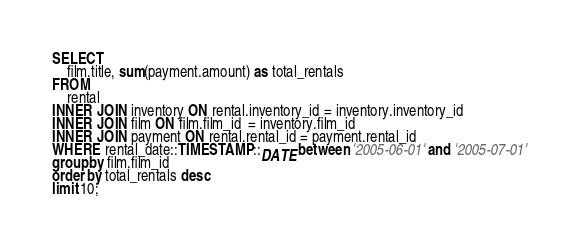Convert code to text. <code><loc_0><loc_0><loc_500><loc_500><_SQL_>SELECT 
	film.title, sum(payment.amount) as total_rentals
FROM 
	rental
INNER JOIN inventory ON rental.inventory_id = inventory.inventory_id
INNER JOIN film ON film.film_id  = inventory.film_id
INNER JOIN payment ON rental.rental_id = payment.rental_id
WHERE rental_date::TIMESTAMP::DATE between '2005-06-01' and '2005-07-01'
group by film.film_id
order by total_rentals desc
limit 10;


</code> 